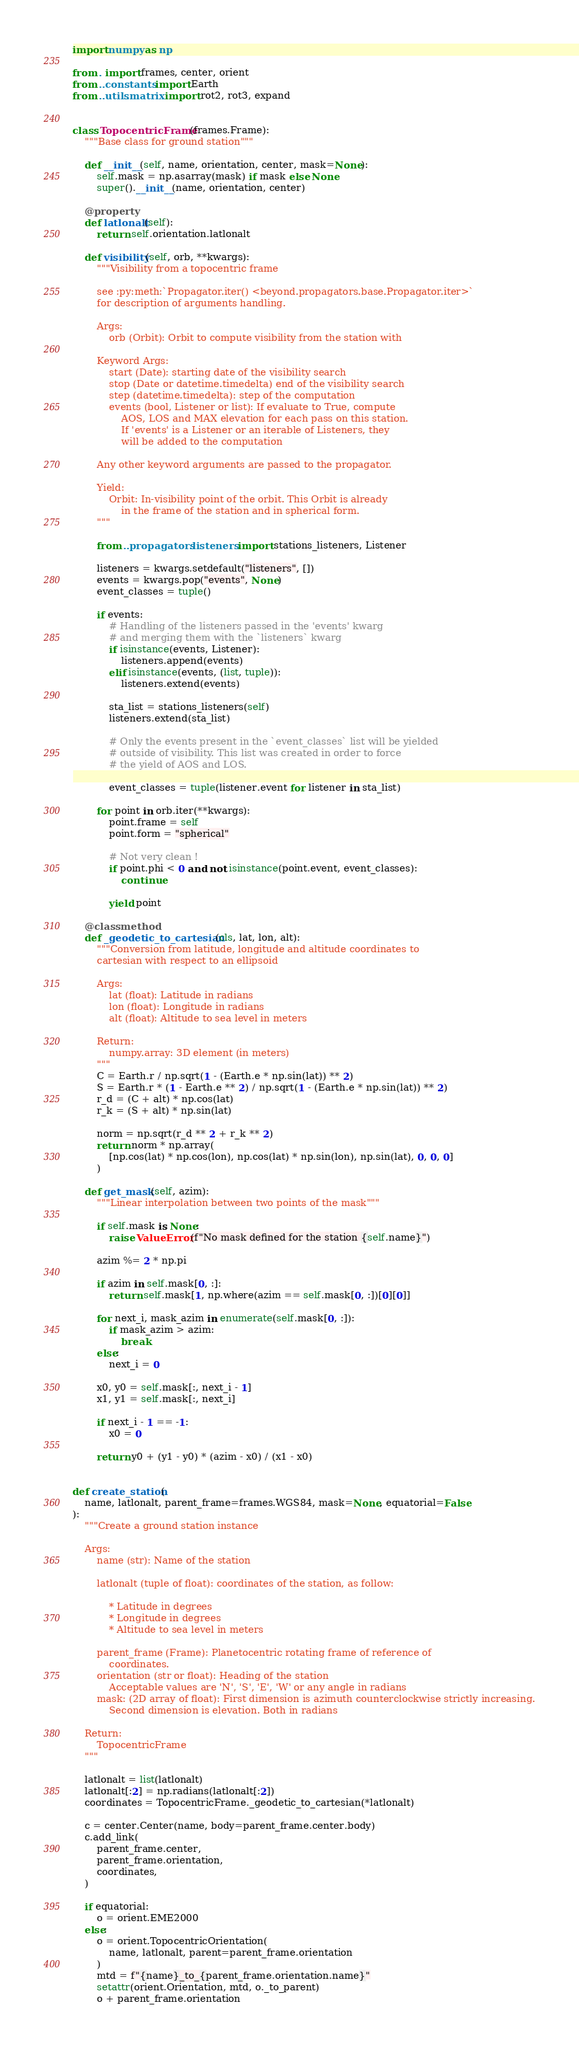<code> <loc_0><loc_0><loc_500><loc_500><_Python_>import numpy as np

from . import frames, center, orient
from ..constants import Earth
from ..utils.matrix import rot2, rot3, expand


class TopocentricFrame(frames.Frame):
    """Base class for ground station"""

    def __init__(self, name, orientation, center, mask=None):
        self.mask = np.asarray(mask) if mask else None
        super().__init__(name, orientation, center)

    @property
    def latlonalt(self):
        return self.orientation.latlonalt

    def visibility(self, orb, **kwargs):
        """Visibility from a topocentric frame

        see :py:meth:`Propagator.iter() <beyond.propagators.base.Propagator.iter>`
        for description of arguments handling.

        Args:
            orb (Orbit): Orbit to compute visibility from the station with

        Keyword Args:
            start (Date): starting date of the visibility search
            stop (Date or datetime.timedelta) end of the visibility search
            step (datetime.timedelta): step of the computation
            events (bool, Listener or list): If evaluate to True, compute
                AOS, LOS and MAX elevation for each pass on this station.
                If 'events' is a Listener or an iterable of Listeners, they
                will be added to the computation

        Any other keyword arguments are passed to the propagator.

        Yield:
            Orbit: In-visibility point of the orbit. This Orbit is already
                in the frame of the station and in spherical form.
        """

        from ..propagators.listeners import stations_listeners, Listener

        listeners = kwargs.setdefault("listeners", [])
        events = kwargs.pop("events", None)
        event_classes = tuple()

        if events:
            # Handling of the listeners passed in the 'events' kwarg
            # and merging them with the `listeners` kwarg
            if isinstance(events, Listener):
                listeners.append(events)
            elif isinstance(events, (list, tuple)):
                listeners.extend(events)

            sta_list = stations_listeners(self)
            listeners.extend(sta_list)

            # Only the events present in the `event_classes` list will be yielded
            # outside of visibility. This list was created in order to force
            # the yield of AOS and LOS.

            event_classes = tuple(listener.event for listener in sta_list)

        for point in orb.iter(**kwargs):
            point.frame = self
            point.form = "spherical"

            # Not very clean !
            if point.phi < 0 and not isinstance(point.event, event_classes):
                continue

            yield point

    @classmethod
    def _geodetic_to_cartesian(cls, lat, lon, alt):
        """Conversion from latitude, longitude and altitude coordinates to
        cartesian with respect to an ellipsoid

        Args:
            lat (float): Latitude in radians
            lon (float): Longitude in radians
            alt (float): Altitude to sea level in meters

        Return:
            numpy.array: 3D element (in meters)
        """
        C = Earth.r / np.sqrt(1 - (Earth.e * np.sin(lat)) ** 2)
        S = Earth.r * (1 - Earth.e ** 2) / np.sqrt(1 - (Earth.e * np.sin(lat)) ** 2)
        r_d = (C + alt) * np.cos(lat)
        r_k = (S + alt) * np.sin(lat)

        norm = np.sqrt(r_d ** 2 + r_k ** 2)
        return norm * np.array(
            [np.cos(lat) * np.cos(lon), np.cos(lat) * np.sin(lon), np.sin(lat), 0, 0, 0]
        )

    def get_mask(self, azim):
        """Linear interpolation between two points of the mask"""

        if self.mask is None:
            raise ValueError(f"No mask defined for the station {self.name}")

        azim %= 2 * np.pi

        if azim in self.mask[0, :]:
            return self.mask[1, np.where(azim == self.mask[0, :])[0][0]]

        for next_i, mask_azim in enumerate(self.mask[0, :]):
            if mask_azim > azim:
                break
        else:
            next_i = 0

        x0, y0 = self.mask[:, next_i - 1]
        x1, y1 = self.mask[:, next_i]

        if next_i - 1 == -1:
            x0 = 0

        return y0 + (y1 - y0) * (azim - x0) / (x1 - x0)


def create_station(
    name, latlonalt, parent_frame=frames.WGS84, mask=None, equatorial=False
):
    """Create a ground station instance

    Args:
        name (str): Name of the station

        latlonalt (tuple of float): coordinates of the station, as follow:

            * Latitude in degrees
            * Longitude in degrees
            * Altitude to sea level in meters

        parent_frame (Frame): Planetocentric rotating frame of reference of
            coordinates.
        orientation (str or float): Heading of the station
            Acceptable values are 'N', 'S', 'E', 'W' or any angle in radians
        mask: (2D array of float): First dimension is azimuth counterclockwise strictly increasing.
            Second dimension is elevation. Both in radians

    Return:
        TopocentricFrame
    """

    latlonalt = list(latlonalt)
    latlonalt[:2] = np.radians(latlonalt[:2])
    coordinates = TopocentricFrame._geodetic_to_cartesian(*latlonalt)

    c = center.Center(name, body=parent_frame.center.body)
    c.add_link(
        parent_frame.center,
        parent_frame.orientation,
        coordinates,
    )

    if equatorial:
        o = orient.EME2000
    else:
        o = orient.TopocentricOrientation(
            name, latlonalt, parent=parent_frame.orientation
        )
        mtd = f"{name}_to_{parent_frame.orientation.name}"
        setattr(orient.Orientation, mtd, o._to_parent)
        o + parent_frame.orientation
</code> 